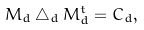<formula> <loc_0><loc_0><loc_500><loc_500>M _ { d } \bigtriangleup _ { d } M _ { d } ^ { t } = C _ { d } ,</formula> 